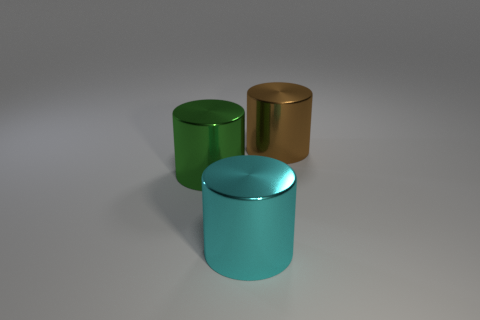Add 3 rubber spheres. How many objects exist? 6 Subtract all big green shiny cylinders. How many cylinders are left? 2 Subtract 1 cylinders. How many cylinders are left? 2 Subtract all green objects. Subtract all cyan shiny cylinders. How many objects are left? 1 Add 1 brown cylinders. How many brown cylinders are left? 2 Add 3 brown things. How many brown things exist? 4 Subtract all brown cylinders. How many cylinders are left? 2 Subtract 1 green cylinders. How many objects are left? 2 Subtract all cyan cylinders. Subtract all green balls. How many cylinders are left? 2 Subtract all purple cubes. How many purple cylinders are left? 0 